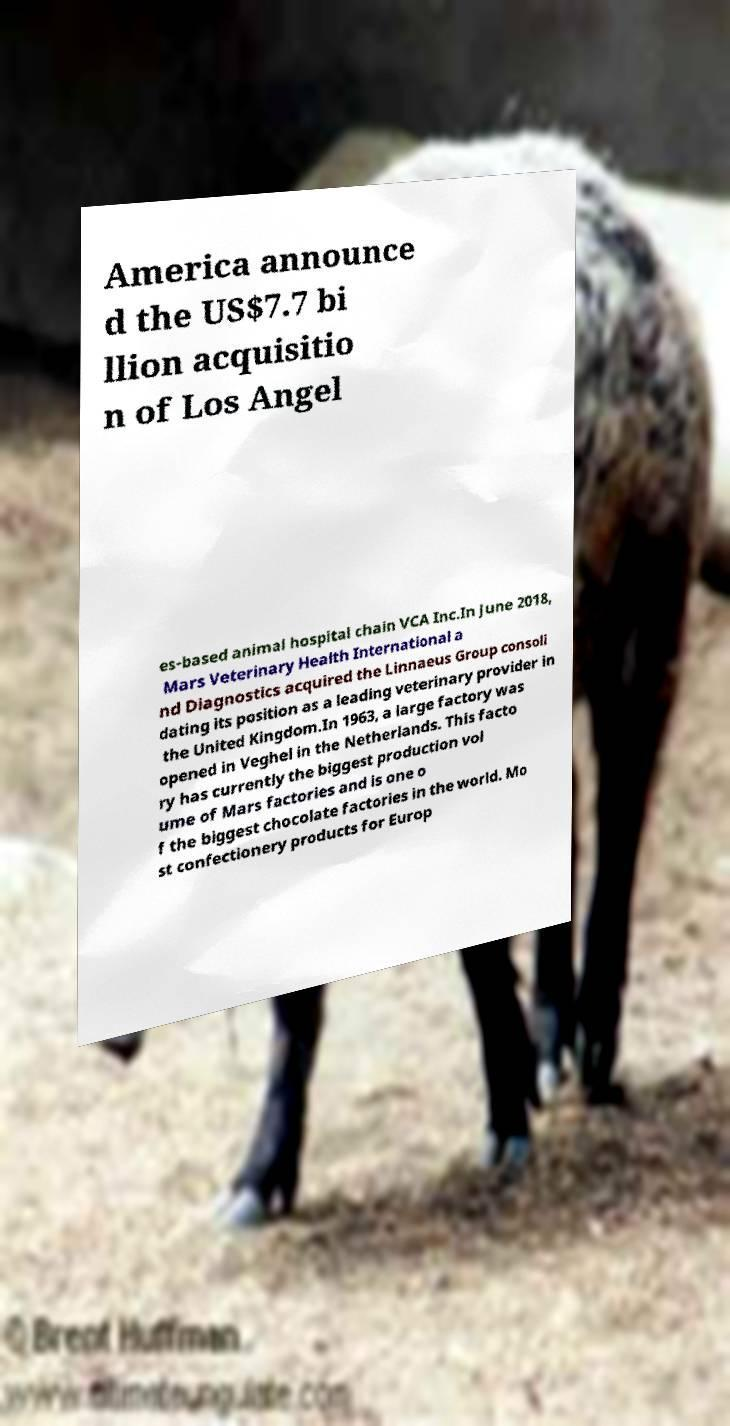Could you extract and type out the text from this image? America announce d the US$7.7 bi llion acquisitio n of Los Angel es-based animal hospital chain VCA Inc.In June 2018, Mars Veterinary Health International a nd Diagnostics acquired the Linnaeus Group consoli dating its position as a leading veterinary provider in the United Kingdom.In 1963, a large factory was opened in Veghel in the Netherlands. This facto ry has currently the biggest production vol ume of Mars factories and is one o f the biggest chocolate factories in the world. Mo st confectionery products for Europ 